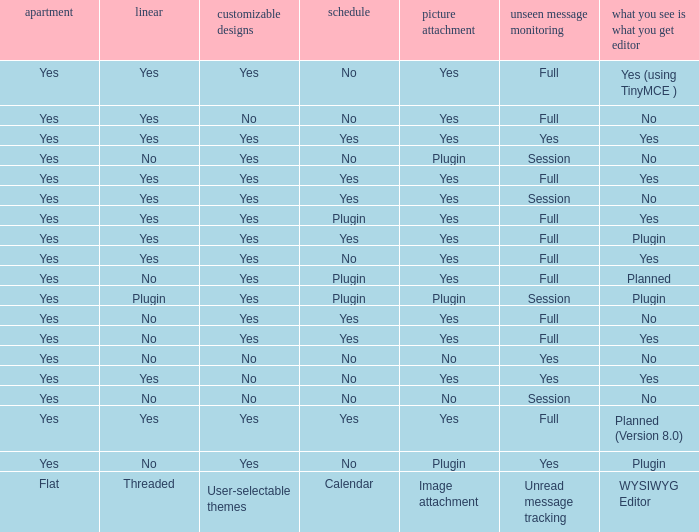Which WYSIWYG Editor has a User-selectable themes of yes, and an Unread message tracking of session, and an Image attachment of plugin? No, Plugin. 